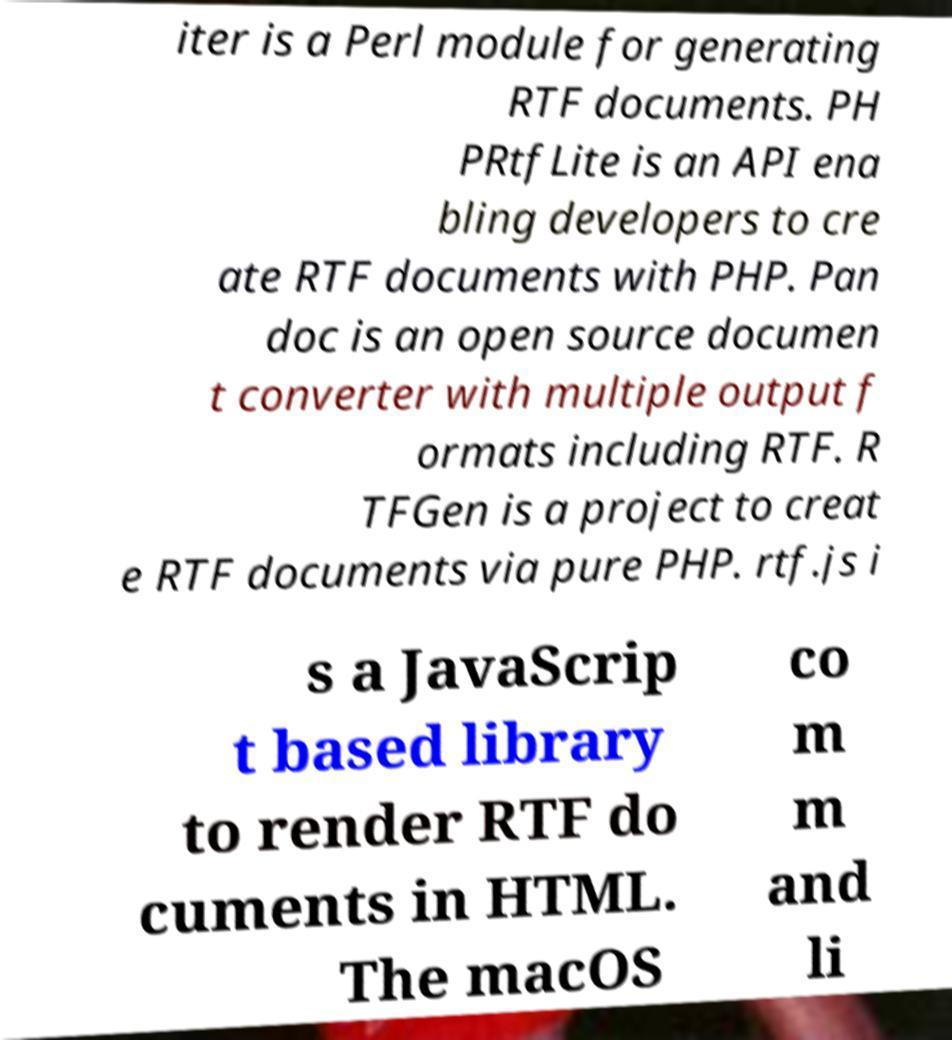Please identify and transcribe the text found in this image. iter is a Perl module for generating RTF documents. PH PRtfLite is an API ena bling developers to cre ate RTF documents with PHP. Pan doc is an open source documen t converter with multiple output f ormats including RTF. R TFGen is a project to creat e RTF documents via pure PHP. rtf.js i s a JavaScrip t based library to render RTF do cuments in HTML. The macOS co m m and li 